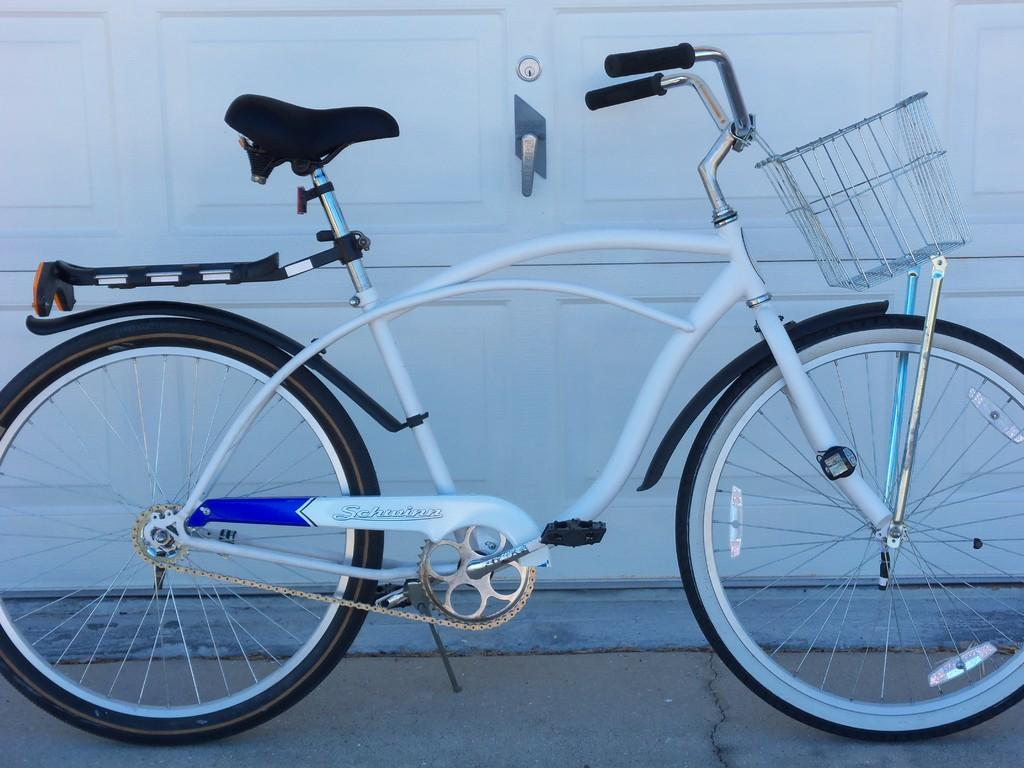What is the main object in the image? There is a bicycle in the image. What type of material is used for the wall in the image? There is a wooden wall in the image. What is the value of the bird in the image? There is no bird present in the image, so it is not possible to determine its value. 